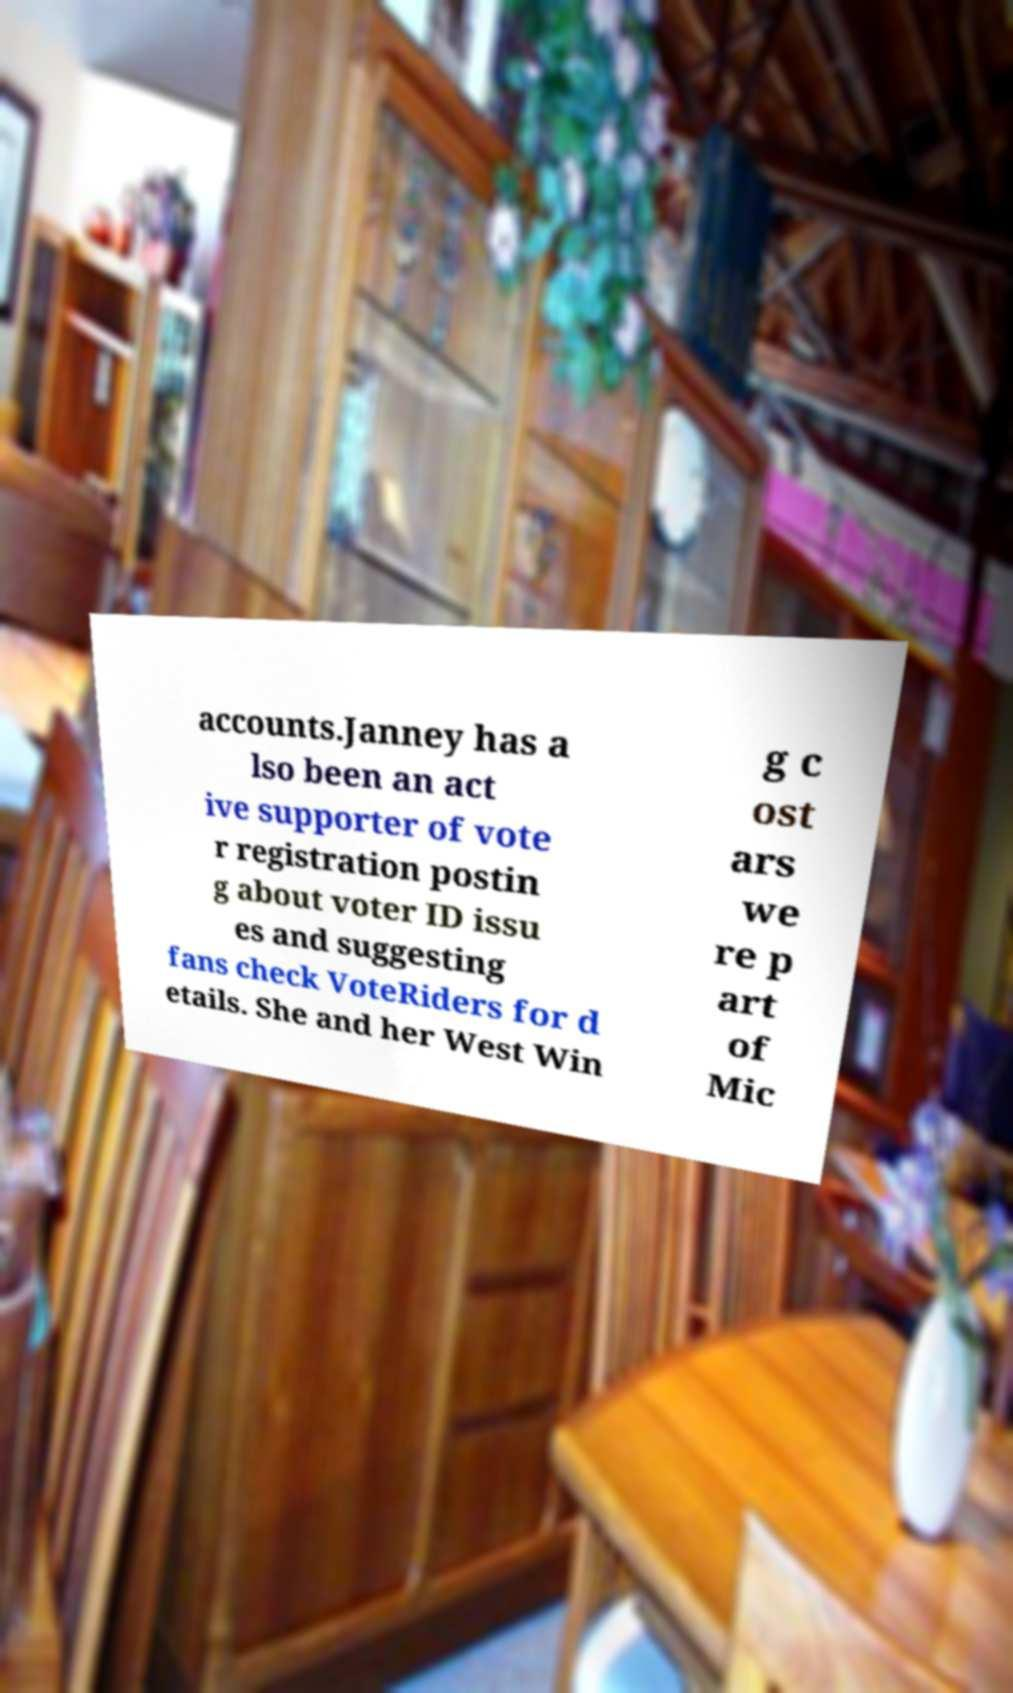Please identify and transcribe the text found in this image. accounts.Janney has a lso been an act ive supporter of vote r registration postin g about voter ID issu es and suggesting fans check VoteRiders for d etails. She and her West Win g c ost ars we re p art of Mic 